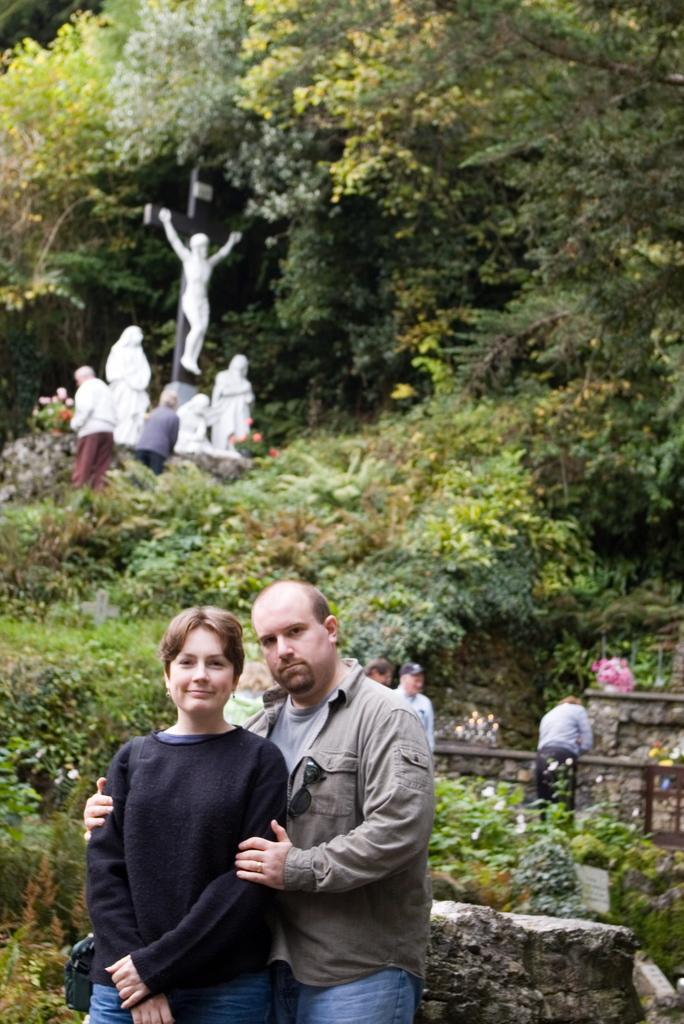Can you describe this image briefly? In this picture we can see a man and a woman are standing in the front, at the bottom there is a rock, we can see some plants, three persons and flowers in the middle, in the background there are trees, statues and two persons. 